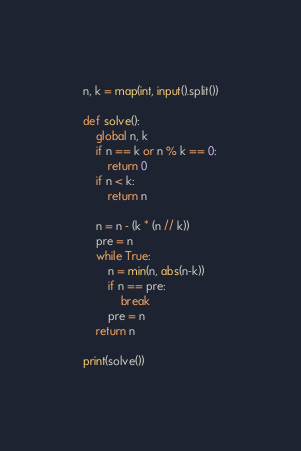<code> <loc_0><loc_0><loc_500><loc_500><_Python_>n, k = map(int, input().split())

def solve():
    global n, k
    if n == k or n % k == 0:
        return 0
    if n < k:
        return n
    
    n = n - (k * (n // k))
    pre = n
    while True:
        n = min(n, abs(n-k))
        if n == pre:
            break
        pre = n
    return n

print(solve())</code> 